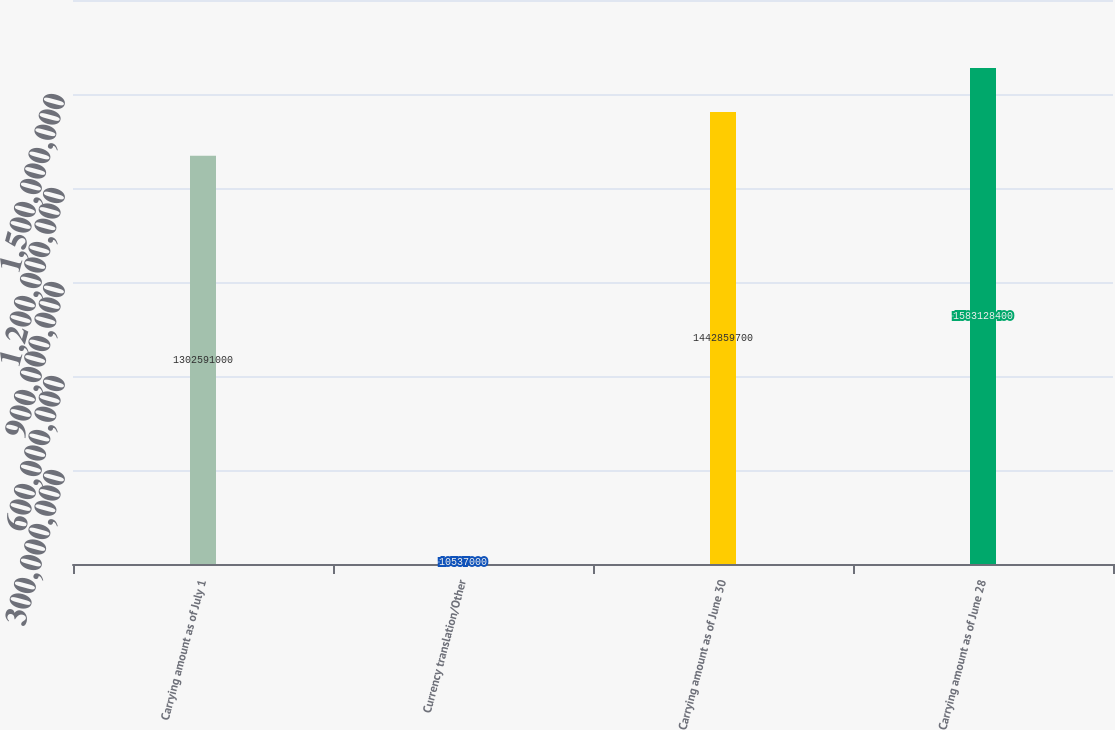Convert chart. <chart><loc_0><loc_0><loc_500><loc_500><bar_chart><fcel>Carrying amount as of July 1<fcel>Currency translation/Other<fcel>Carrying amount as of June 30<fcel>Carrying amount as of June 28<nl><fcel>1.30259e+09<fcel>1.0537e+07<fcel>1.44286e+09<fcel>1.58313e+09<nl></chart> 